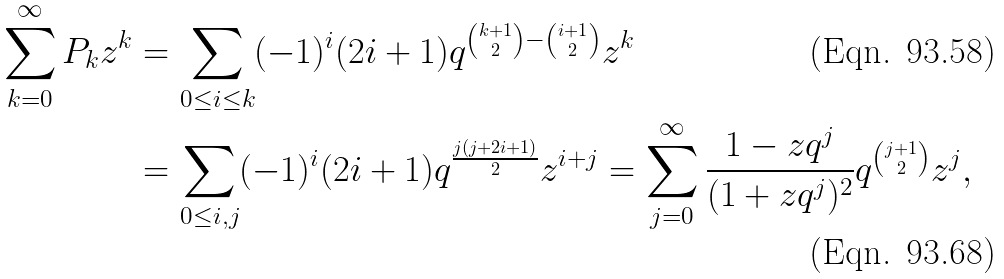Convert formula to latex. <formula><loc_0><loc_0><loc_500><loc_500>\sum _ { k = 0 } ^ { \infty } P _ { k } z ^ { k } & = \sum _ { 0 \leq i \leq k } ( - 1 ) ^ { i } ( 2 i + 1 ) q ^ { \binom { k + 1 } 2 - \binom { i + 1 } 2 } z ^ { k } \\ & = \sum _ { 0 \leq i , j } ( - 1 ) ^ { i } ( 2 i + 1 ) q ^ { \frac { j ( j + 2 i + 1 ) } 2 } z ^ { i + j } = \sum _ { j = 0 } ^ { \infty } \frac { 1 - z q ^ { j } } { ( 1 + z q ^ { j } ) ^ { 2 } } q ^ { \binom { j + 1 } 2 } z ^ { j } ,</formula> 